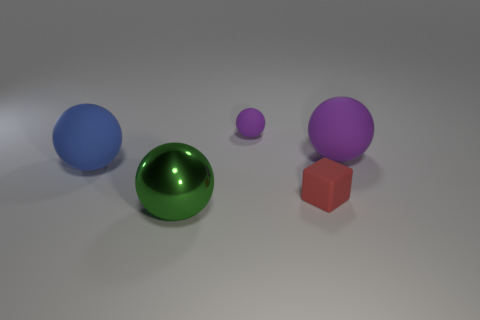Can you describe the lighting in the scene? The lighting in the scene appears to be soft and diffused, coming from above. Shadows under the objects are slight and elongated, indicating the light source is not directly overhead but somewhat angled. There's no harsh glare, suggesting that the light source might be large or there might be multiple light sources. 